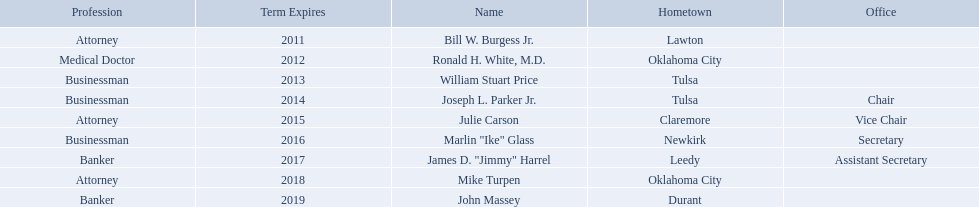Which regents are from tulsa? William Stuart Price, Joseph L. Parker Jr. Which of these is not joseph parker, jr.? William Stuart Price. What are all the names of oklahoma state regents for higher educations? Bill W. Burgess Jr., Ronald H. White, M.D., William Stuart Price, Joseph L. Parker Jr., Julie Carson, Marlin "Ike" Glass, James D. "Jimmy" Harrel, Mike Turpen, John Massey. Which ones are businessmen? William Stuart Price, Joseph L. Parker Jr., Marlin "Ike" Glass. Of those, who is from tulsa? William Stuart Price, Joseph L. Parker Jr. Whose term expires in 2014? Joseph L. Parker Jr. Who are the regents? Bill W. Burgess Jr., Ronald H. White, M.D., William Stuart Price, Joseph L. Parker Jr., Julie Carson, Marlin "Ike" Glass, James D. "Jimmy" Harrel, Mike Turpen, John Massey. Of these who is a businessman? William Stuart Price, Joseph L. Parker Jr., Marlin "Ike" Glass. Of these whose hometown is tulsa? William Stuart Price, Joseph L. Parker Jr. Of these whose term expires in 2013? William Stuart Price. 